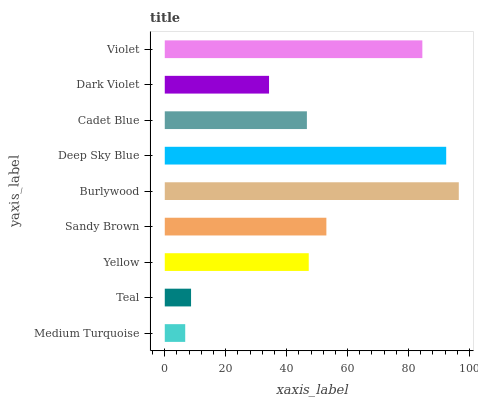Is Medium Turquoise the minimum?
Answer yes or no. Yes. Is Burlywood the maximum?
Answer yes or no. Yes. Is Teal the minimum?
Answer yes or no. No. Is Teal the maximum?
Answer yes or no. No. Is Teal greater than Medium Turquoise?
Answer yes or no. Yes. Is Medium Turquoise less than Teal?
Answer yes or no. Yes. Is Medium Turquoise greater than Teal?
Answer yes or no. No. Is Teal less than Medium Turquoise?
Answer yes or no. No. Is Yellow the high median?
Answer yes or no. Yes. Is Yellow the low median?
Answer yes or no. Yes. Is Medium Turquoise the high median?
Answer yes or no. No. Is Deep Sky Blue the low median?
Answer yes or no. No. 